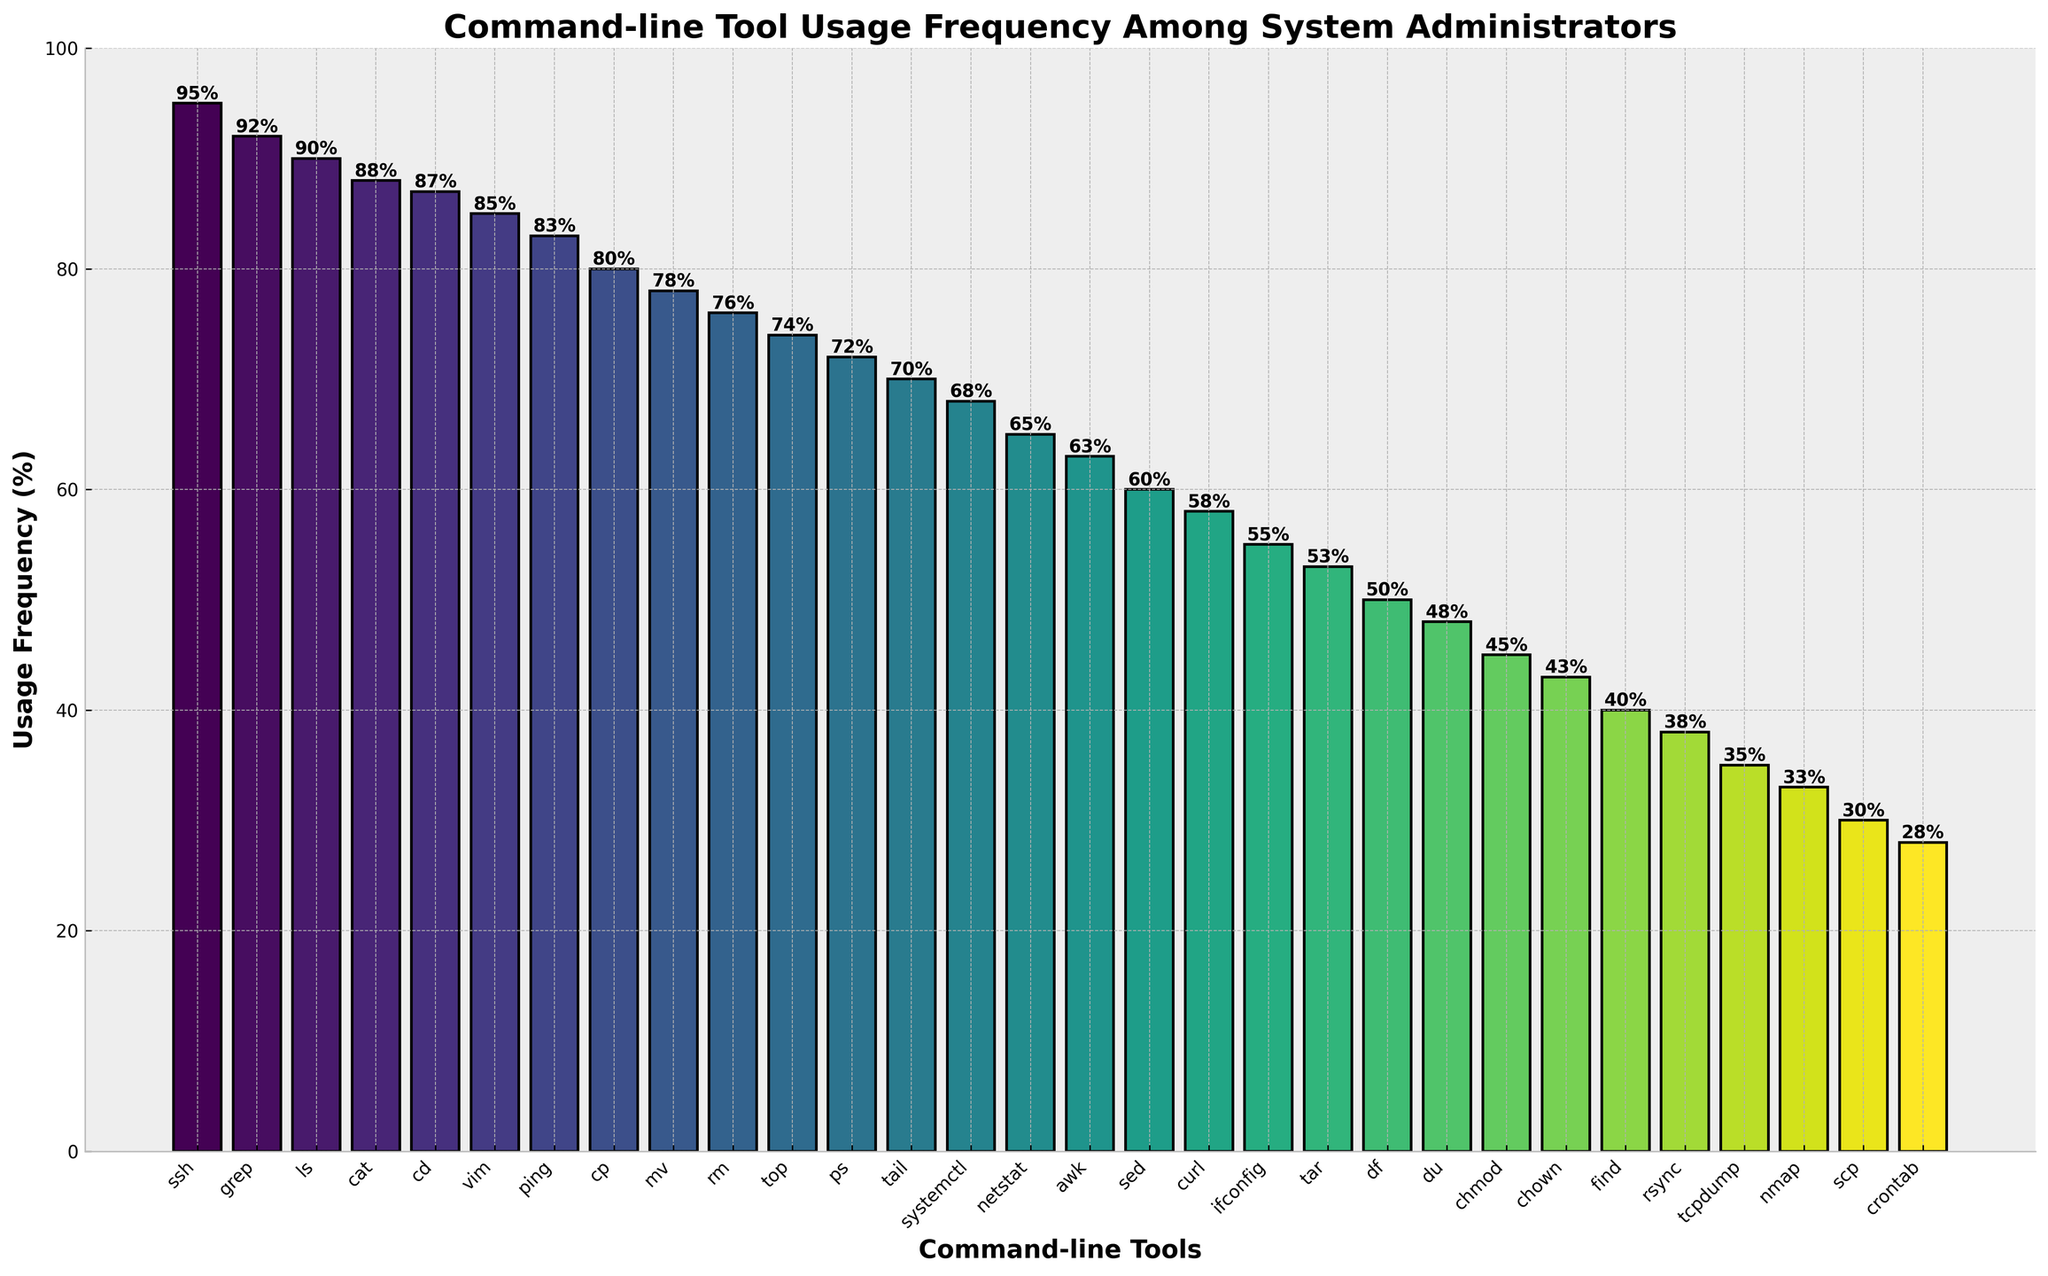Which command-line tool has the highest usage frequency? The figure shows a bar chart representing the usage frequency of various command-line tools among system administrators. The tool with the tallest bar represents the highest usage frequency. From the chart, it's evident that "ssh" has the highest bar, indicating the highest usage frequency.
Answer: ssh Which tools have a usage frequency greater than `80%`? To determine which tools have a usage frequency greater than 80%, we need to identify the bars that extend above the 80% mark on the y-axis. The tools with usage frequencies above 80% are "ssh," "grep," "ls," "cat," "cd," "vim," and "ping."
Answer: ssh, grep, ls, cat, cd, vim, ping Which tool has a lower usage frequency: `sed` or `awk`? To compare the usage frequencies of 'sed' and 'awk,' we need to look at the heights of the respective bars. The bar for 'sed' is shorter than the bar for 'awk,' indicating that 'sed' has a lower usage frequency.
Answer: sed What's the total usage frequency of the top 3 most used tools? Identify the top three tools with the highest bars: 'ssh' (95%), 'grep' (92%), and 'ls' (90%). Add these frequencies together: 95 + 92 + 90 = 277.
Answer: 277 What is the difference in usage frequency between `nmap` and `rsync`? Examine the heights of the bars for 'nmap' (33%) and 'rsync' (38%). Calculate the difference: (38 - 33) = 5.
Answer: 5 What’s the average usage frequency of the three least used tools? Identify the three tools with the lowest bars: 'crontab' (28%), 'scp' (30%), and 'nmap' (33%). Calculate the average usage frequency: (28 + 30 + 33) / 3 = 30.33.
Answer: 30.33 Which tool has the highest usage frequency among those starting with the letter `c`? Identify the tools starting with 'c': 'cat,' 'cd,' 'cp,' 'curl,' 'chmod,' 'chown,' and 'crontab.' From these, 'cat' has the highest usage frequency (88%).
Answer: cat Find the median usage frequency of all the tools listed. List the usage frequencies in ascending order: 28, 30, 33, 35, 38, 40, 43, 45, 48, 50, 53, 55, 58, 60, 63, 65, 68, 70, 72, 74, 76, 78, 80, 83, 85, 87, 88, 90, 92, 95. With 30 tools, the median is the average of the 15th and 16th values: (63 + 60) / 2 = 61.5.
Answer: 61.5 